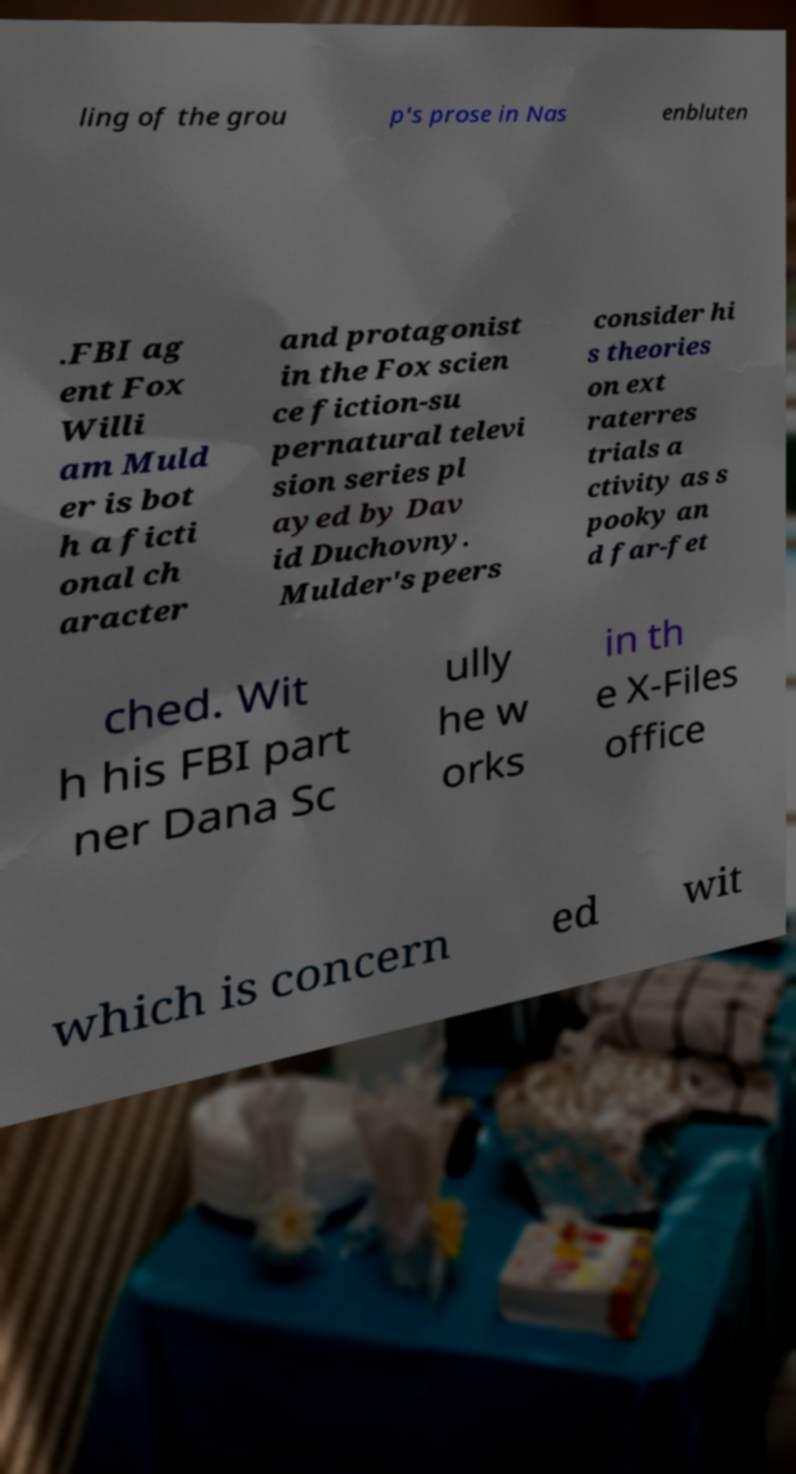Could you assist in decoding the text presented in this image and type it out clearly? ling of the grou p's prose in Nas enbluten .FBI ag ent Fox Willi am Muld er is bot h a ficti onal ch aracter and protagonist in the Fox scien ce fiction-su pernatural televi sion series pl ayed by Dav id Duchovny. Mulder's peers consider hi s theories on ext raterres trials a ctivity as s pooky an d far-fet ched. Wit h his FBI part ner Dana Sc ully he w orks in th e X-Files office which is concern ed wit 